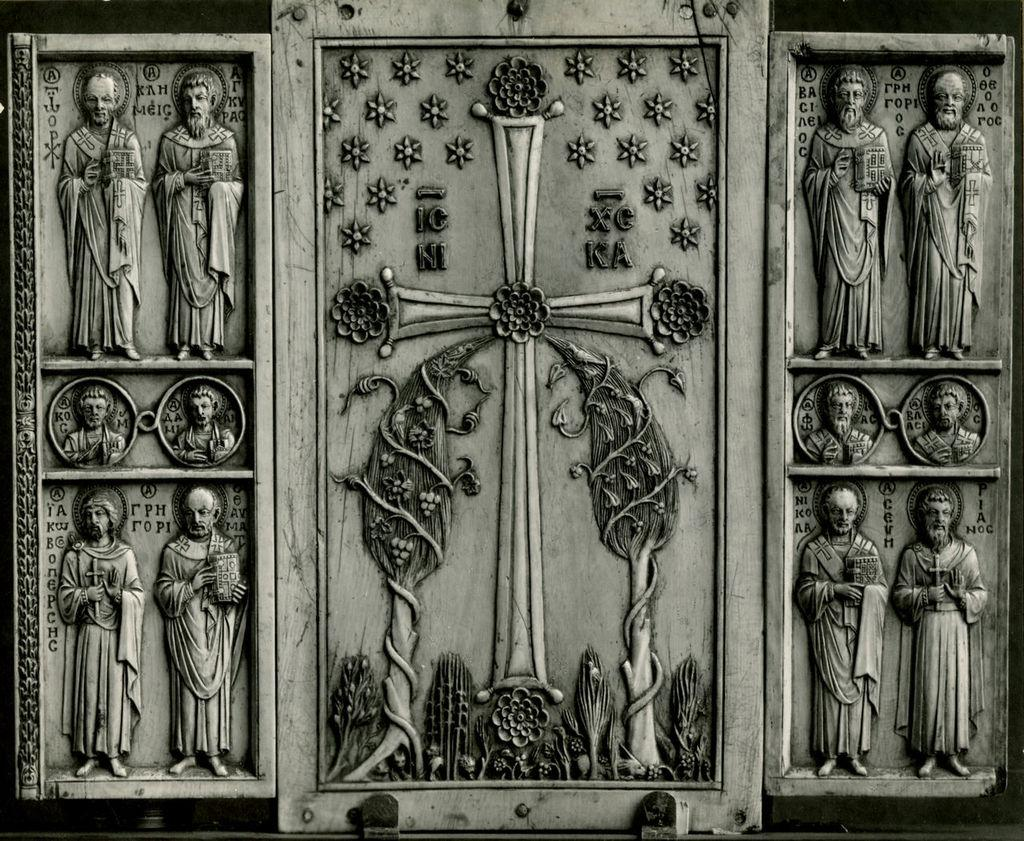What type of frames are visible in the image? There are wooden frames in the image. What is displayed on the wooden frames? There are sculptures on the wooden frames. Where are the ants crawling on the wooden frames in the image? There are no ants present in the image; it only features wooden frames with sculptures on them. 